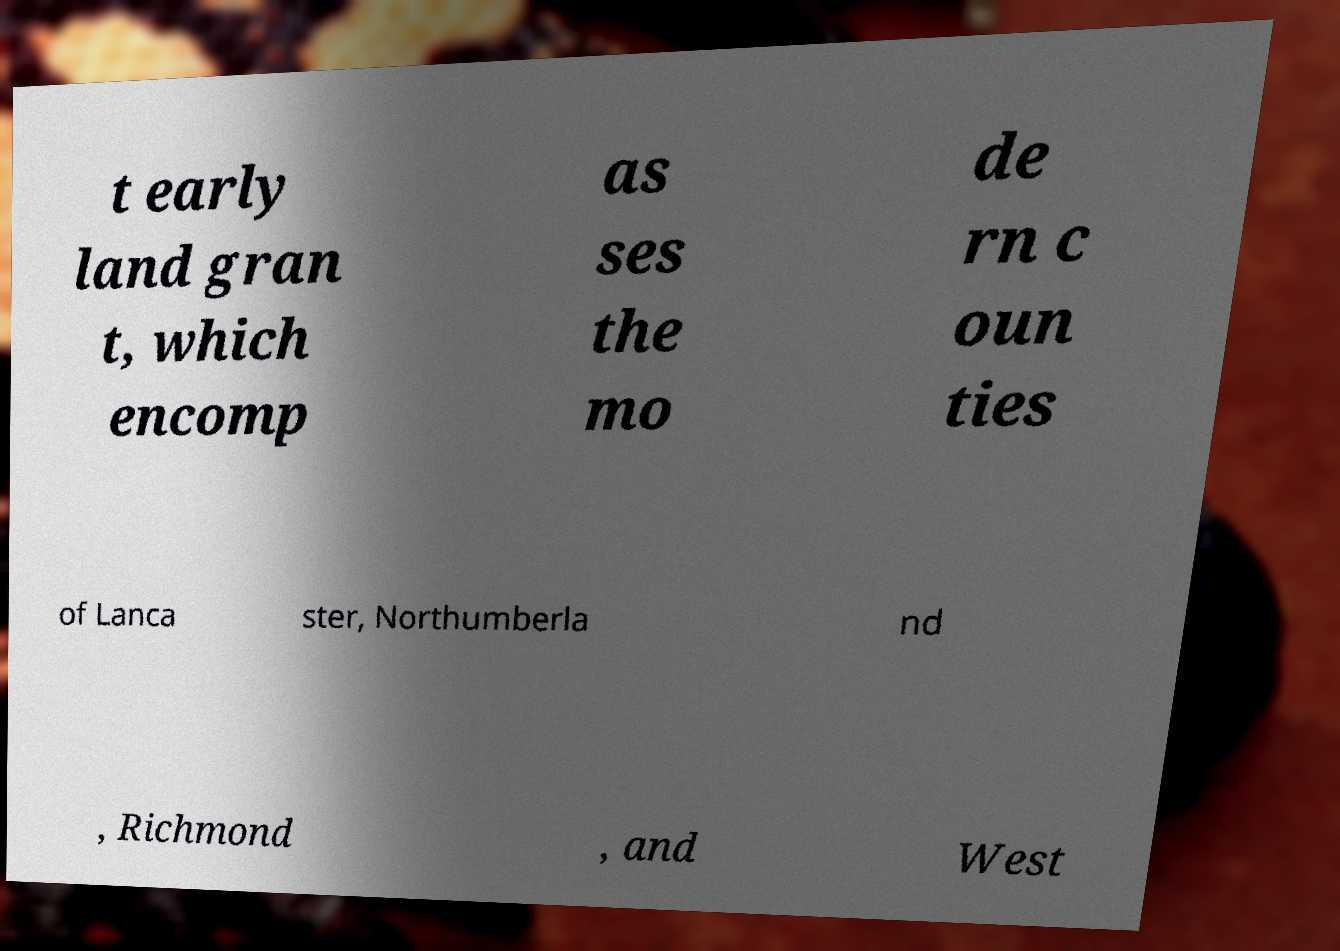What messages or text are displayed in this image? I need them in a readable, typed format. t early land gran t, which encomp as ses the mo de rn c oun ties of Lanca ster, Northumberla nd , Richmond , and West 